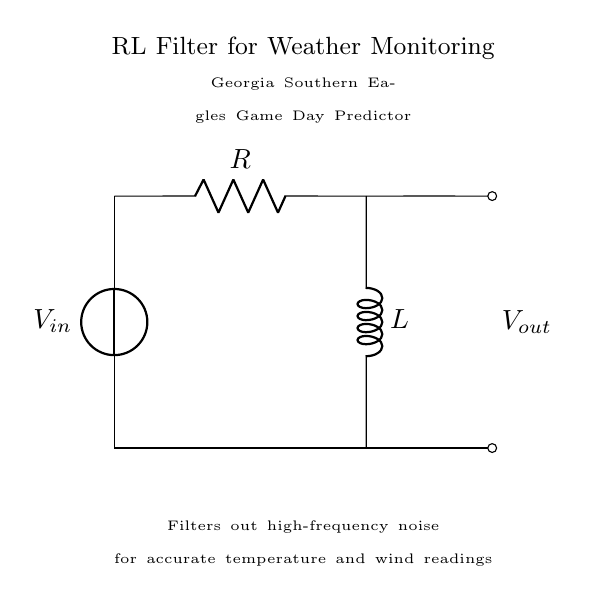What is the input voltage source in this circuit? The input voltage source is labeled as Vin, which represents the input voltage provided to the circuit.
Answer: Vin What type of filter is represented in this circuit? The circuit diagram shows an RL filter, which consists of a resistor and an inductor used together to filter signals.
Answer: RL filter What components are present in the circuit? The circuit includes two components: a resistor labeled R and an inductor labeled L, which are connected in series.
Answer: Resistor and Inductor What is the purpose of this RL filter in the context provided? The purpose of the RL filter is to filter out high-frequency noise, enabling accurate temperature and wind readings for weather monitoring.
Answer: Filter out noise How does the inductor affect the circuit at high frequencies? At high frequencies, inductors provide high impedance, which prevents high-frequency noise from passing through, thereby filtering the output.
Answer: High impedance What is the output voltage labeled in the circuit diagram? The output voltage is indicated as Vout, which represents the voltage across the load or the output of the filter circuit.
Answer: Vout 